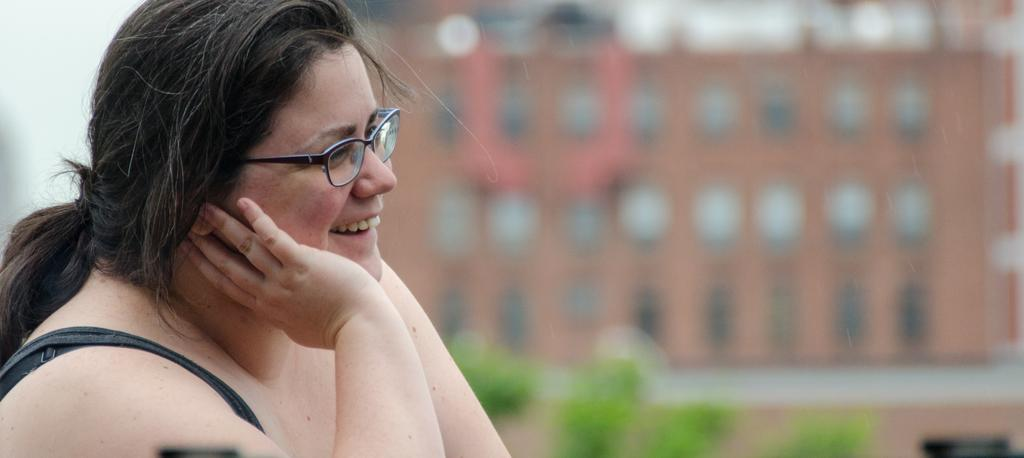Who is present in the image? There is a woman in the image. What is the woman wearing on her face? The woman is wearing spectacles. What expression does the woman have? The woman is smiling. What can be seen in the background of the image? There is a building and plants in the background of the image. How would you describe the background in the image? The background is blurry. What type of wood can be seen in the image? There is no wood present in the image. What is the reason for the wire being stretched across the image? There is no wire present in the image, so it cannot be determined why it might be stretched across the image. 